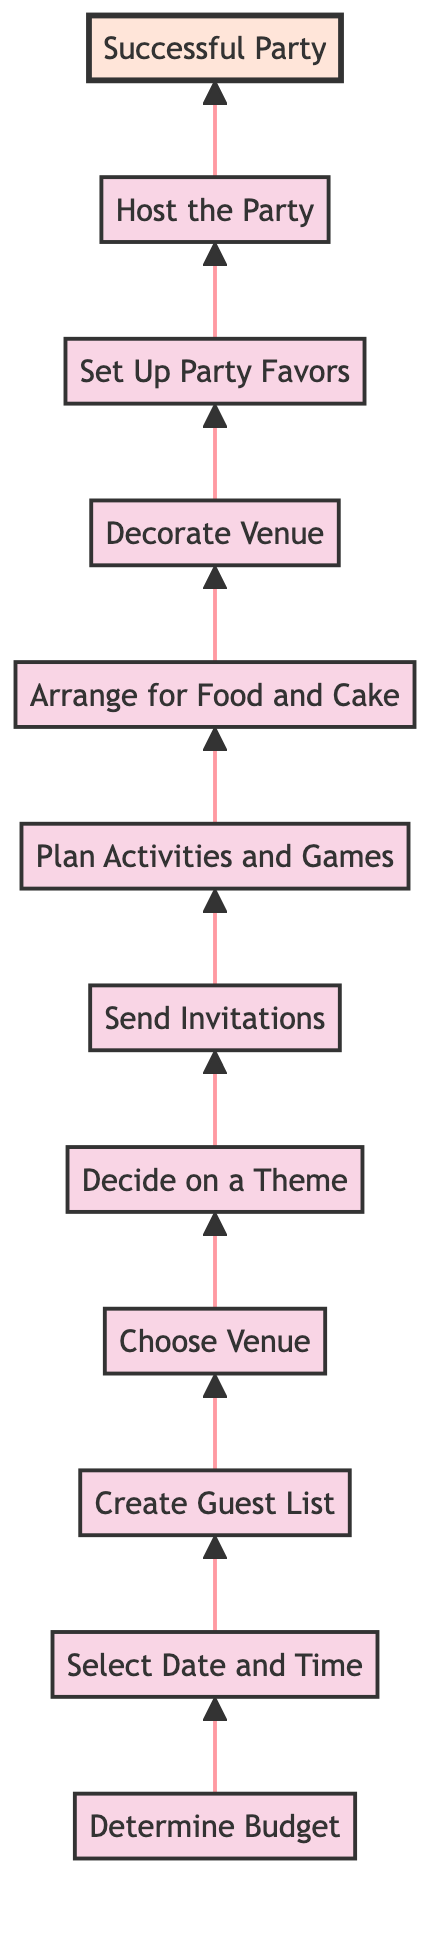What is the first step in planning a child's birthday party? The diagram shows that the first step is "Determine Budget." This is positioned at the bottom of the flowchart, indicating it is the starting point for the process.
Answer: Determine Budget How many steps are there in total from planning to success? By counting the nodes in the diagram, there are a total of 12 steps that flow from the bottom (planning) to the top (successful party). Each step represents a different stage in the party planning process.
Answer: 12 What is the last step in the process? The final step at the top of the diagram is "Successful Party." This is the culmination of all previous steps and the goal of the planning process.
Answer: Successful Party What step comes immediately after selecting a date and time? According to the flowchart, after "Select Date and Time," the next step is "Create Guest List." This indicates a sequential progression in the planning stages.
Answer: Create Guest List What do you do before sending invitations? Before sending invitations, you must "Decide on a Theme." This two-step process emphasizes that knowing the theme is important for crafting appropriate invitations.
Answer: Decide on a Theme What must be done after arranging for food and cake? The flowchart indicates that after "Arrange for Food and Cake," the next action is to "Decorate Venue." This highlights the ongoing nature of party preparation that includes both food and decor.
Answer: Decorate Venue How do the activities relate to planning the birthday party? "Plan Activities and Games" is a crucial step that occurs after sending invitations and before arranging food. This shows that planning engaging content is an integral part of preparing a fun party.
Answer: Plan Activities and Games Which step occurs right before hosting the party? The step immediately prior to "Host the Party" is "Set Up Party Favors." This means that final touches and preparations are being made for the guests right before the party begins.
Answer: Set Up Party Favors What key decision follows choosing a venue? After "Choose Venue," the next important decision is "Decide on a Theme." This highlights that venue selection influences the decision on how to theme the party.
Answer: Decide on a Theme 